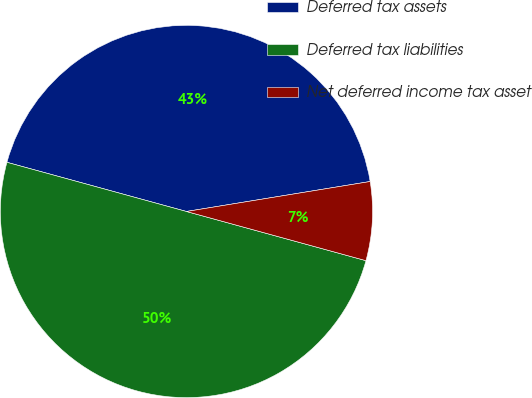<chart> <loc_0><loc_0><loc_500><loc_500><pie_chart><fcel>Deferred tax assets<fcel>Deferred tax liabilities<fcel>Net deferred income tax asset<nl><fcel>43.17%<fcel>50.0%<fcel>6.83%<nl></chart> 